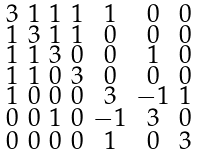Convert formula to latex. <formula><loc_0><loc_0><loc_500><loc_500>\begin{smallmatrix} 3 & 1 & 1 & 1 & 1 & 0 & 0 \\ 1 & 3 & 1 & 1 & 0 & 0 & 0 \\ 1 & 1 & 3 & 0 & 0 & 1 & 0 \\ 1 & 1 & 0 & 3 & 0 & 0 & 0 \\ 1 & 0 & 0 & 0 & 3 & - 1 & 1 \\ 0 & 0 & 1 & 0 & - 1 & 3 & 0 \\ 0 & 0 & 0 & 0 & 1 & 0 & 3 \end{smallmatrix}</formula> 